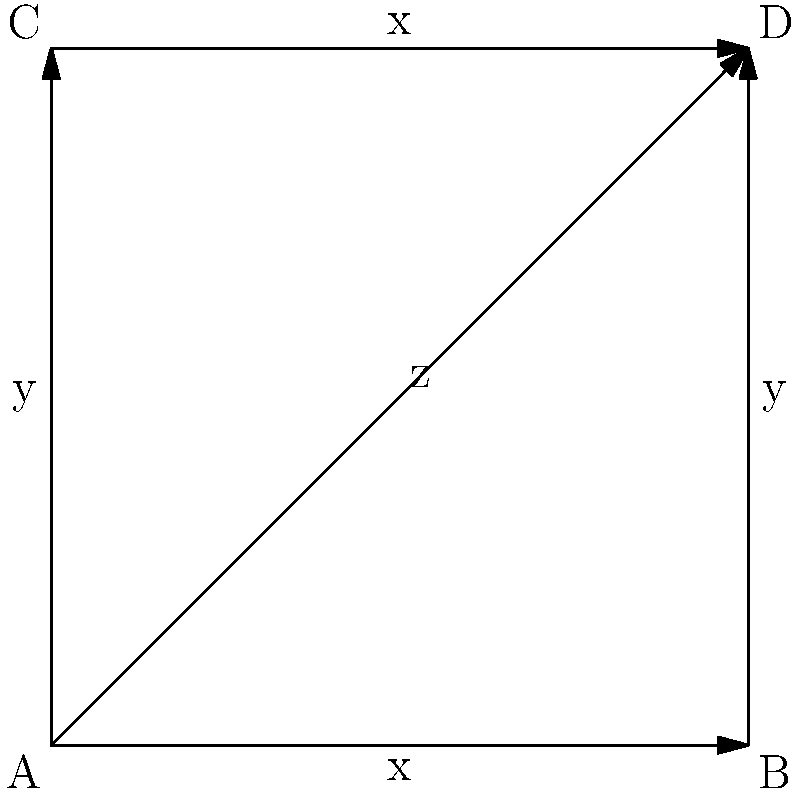In the context of vulnerability patching teams, consider the Cayley graph above representing a group of four team members (A, B, C, D) and their relationships. The edges represent different types of vulnerabilities (x, y, z) that team members can address. If a team member can only move along one edge at a time, what is the minimum number of steps required for member A to reach member D and patch all types of vulnerabilities? To solve this problem, we need to analyze the Cayley graph and find the shortest path from A to D that includes all three types of vulnerabilities (x, y, and z). Let's break it down step-by-step:

1. Observe the graph:
   - Vertices A, B, C, and D represent team members
   - Edges x, y, and z represent different types of vulnerabilities

2. Identify possible paths from A to D:
   - A → B → D (2 steps, covers x and y)
   - A → C → D (2 steps, covers y and x)
   - A → D (1 step, covers only z)

3. Determine the minimum number of steps to cover all vulnerabilities:
   - We need to cover x, y, and z
   - The direct path A → D only covers z
   - We must use at least one additional step to cover x and y

4. Find the optimal path:
   - A → B → D covers x and y, and takes 2 steps
   - Then, we need to cover z, which requires one more step
   - Total steps: 3

5. Verify that this is the minimum:
   - Any other path that covers all vulnerabilities will require at least 3 steps

Therefore, the minimum number of steps required for member A to reach member D and patch all types of vulnerabilities is 3.
Answer: 3 steps 